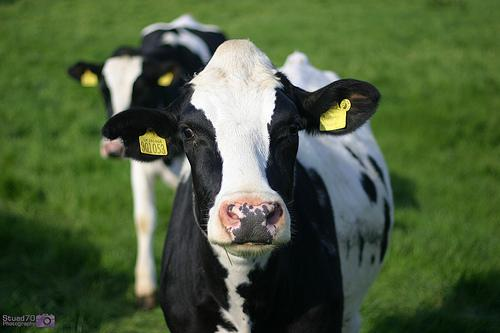Question: where is the cow?
Choices:
A. In a barn.
B. In a grassy field.
C. At a farm.
D. In a truck.
Answer with the letter. Answer: B Question: what is the cow doing?
Choices:
A. Standing.
B. Laying down.
C. Eating.
D. Sleeping.
Answer with the letter. Answer: A Question: how many cows are there?
Choices:
A. Two.
B. Five.
C. Three.
D. Four.
Answer with the letter. Answer: A Question: why are there yellow tags in the cow's ears?
Choices:
A. For decoration.
B. To mark ownership.
C. For identification.
D. To find when lost.
Answer with the letter. Answer: C Question: how many yellow ear tags are visible?
Choices:
A. Five.
B. One.
C. Seven.
D. Four.
Answer with the letter. Answer: D Question: what color are the ear tags?
Choices:
A. Black.
B. Yellow.
C. Red.
D. Orange.
Answer with the letter. Answer: B 